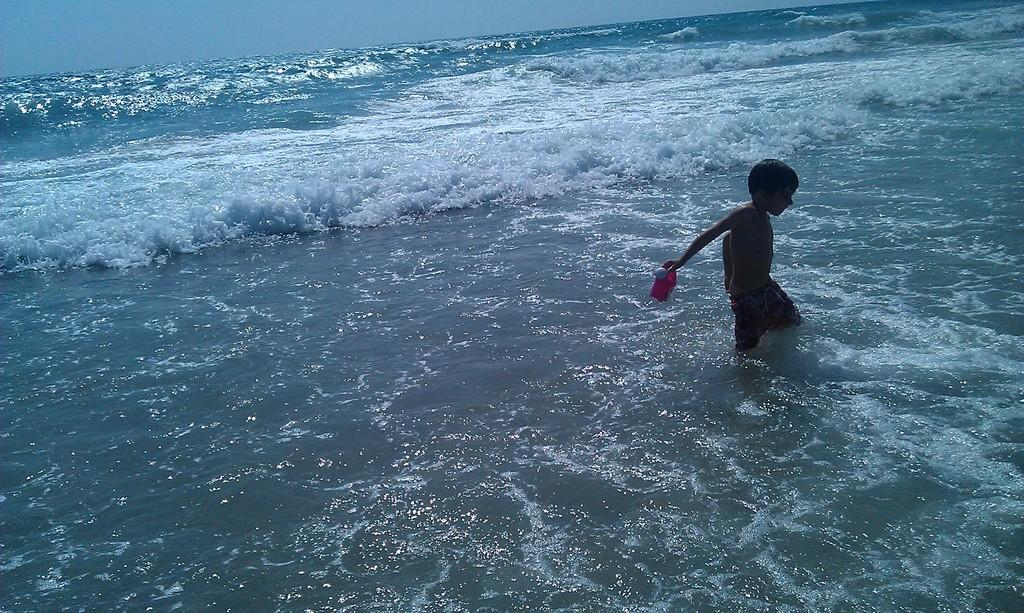What is the main feature of the image? There is an ocean in the image. Where is the boy located in the image? The boy is on the right side of the image. What is the boy wearing? The boy is wearing a short. What is the boy holding in his hand? The boy is holding an object in his hand. What is the boy's position in relation to the water? The boy is standing in the water. What is visible at the top of the image? The sky is visible at the top of the image. Where is the faucet located in the image? There is no faucet present in the image. What type of crib is visible in the image? There is no crib present in the image. 